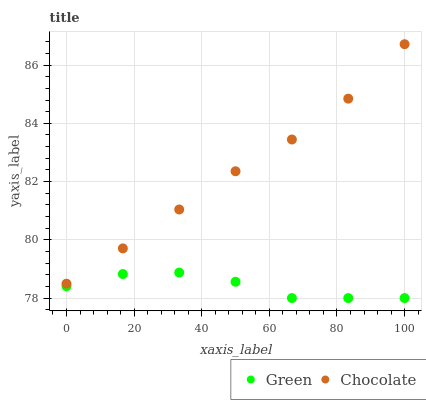Does Green have the minimum area under the curve?
Answer yes or no. Yes. Does Chocolate have the maximum area under the curve?
Answer yes or no. Yes. Does Chocolate have the minimum area under the curve?
Answer yes or no. No. Is Chocolate the smoothest?
Answer yes or no. Yes. Is Green the roughest?
Answer yes or no. Yes. Is Chocolate the roughest?
Answer yes or no. No. Does Green have the lowest value?
Answer yes or no. Yes. Does Chocolate have the lowest value?
Answer yes or no. No. Does Chocolate have the highest value?
Answer yes or no. Yes. Is Green less than Chocolate?
Answer yes or no. Yes. Is Chocolate greater than Green?
Answer yes or no. Yes. Does Green intersect Chocolate?
Answer yes or no. No. 